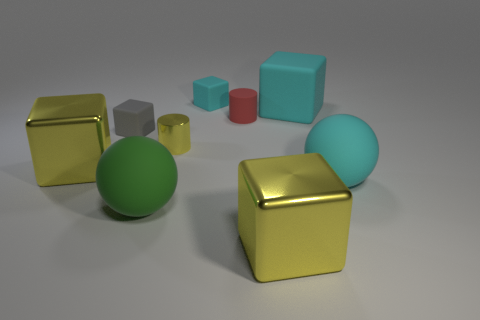Subtract all gray matte blocks. How many blocks are left? 4 Subtract all gray cubes. How many cubes are left? 4 Subtract all gray blocks. Subtract all cyan spheres. How many blocks are left? 4 Add 1 small gray rubber objects. How many objects exist? 10 Subtract all cylinders. How many objects are left? 7 Subtract all metal cylinders. Subtract all small matte cylinders. How many objects are left? 7 Add 8 tiny cyan things. How many tiny cyan things are left? 9 Add 3 gray matte cubes. How many gray matte cubes exist? 4 Subtract 0 blue spheres. How many objects are left? 9 